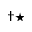Convert formula to latex. <formula><loc_0><loc_0><loc_500><loc_500>^ { \dag ^ { * } }</formula> 